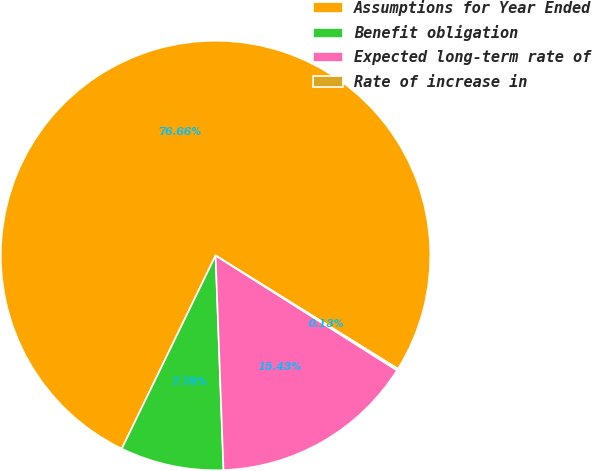<chart> <loc_0><loc_0><loc_500><loc_500><pie_chart><fcel>Assumptions for Year Ended<fcel>Benefit obligation<fcel>Expected long-term rate of<fcel>Rate of increase in<nl><fcel>76.66%<fcel>7.78%<fcel>15.43%<fcel>0.13%<nl></chart> 